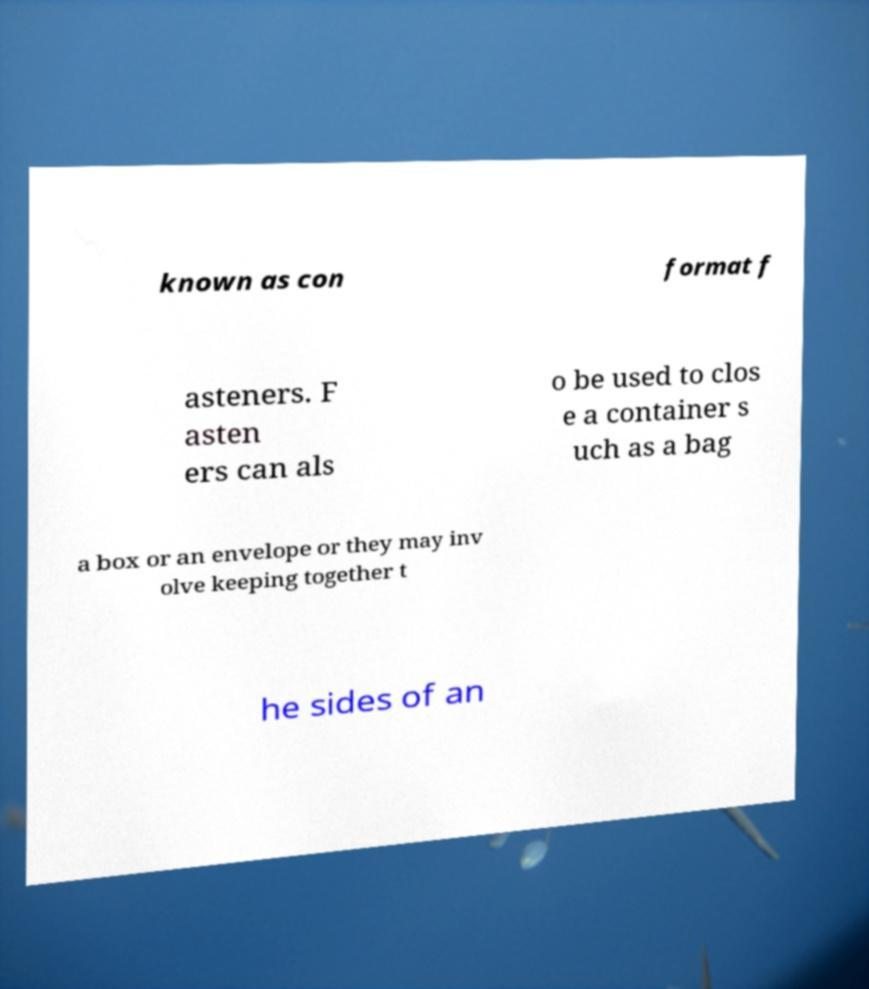For documentation purposes, I need the text within this image transcribed. Could you provide that? known as con format f asteners. F asten ers can als o be used to clos e a container s uch as a bag a box or an envelope or they may inv olve keeping together t he sides of an 